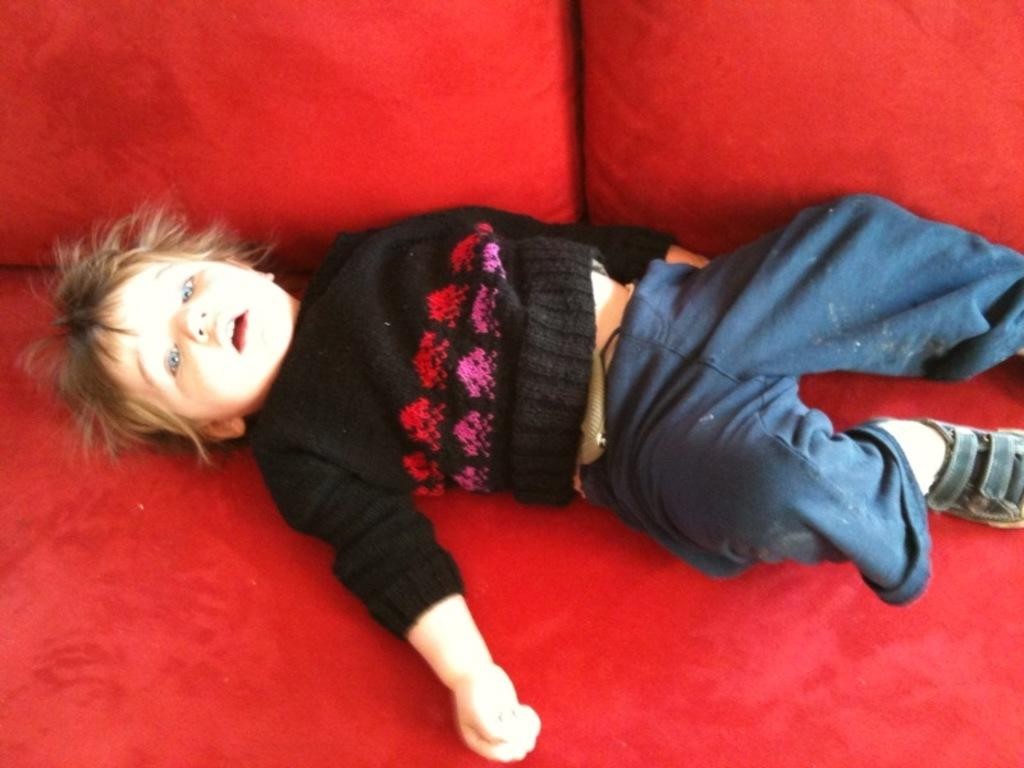What is the main subject of the image? There is a child in the image. What is the child wearing? The child is wearing a black t-shirt. What is the child lying on? The child is lying on a red cloth. Are there any other objects related to the child's comfort in the image? Yes, there are two red pillows in the image. What type of knowledge can be gained from the hill in the image? There is no hill present in the image, so no knowledge can be gained from it. 